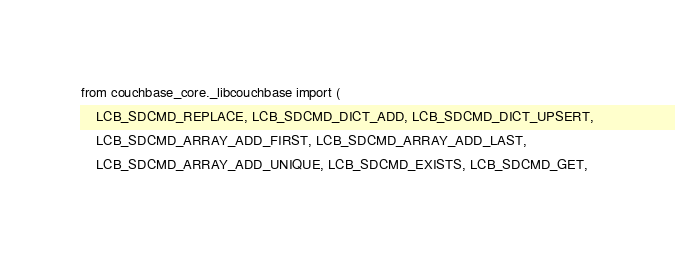Convert code to text. <code><loc_0><loc_0><loc_500><loc_500><_Python_>from couchbase_core._libcouchbase import (
    LCB_SDCMD_REPLACE, LCB_SDCMD_DICT_ADD, LCB_SDCMD_DICT_UPSERT,
    LCB_SDCMD_ARRAY_ADD_FIRST, LCB_SDCMD_ARRAY_ADD_LAST,
    LCB_SDCMD_ARRAY_ADD_UNIQUE, LCB_SDCMD_EXISTS, LCB_SDCMD_GET,</code> 